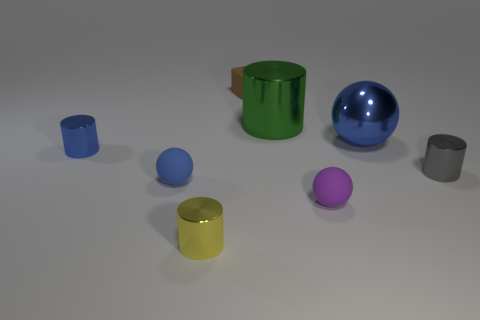Add 2 metal balls. How many objects exist? 10 Subtract all balls. How many objects are left? 5 Add 7 big brown metallic balls. How many big brown metallic balls exist? 7 Subtract 0 brown cylinders. How many objects are left? 8 Subtract all blue objects. Subtract all tiny gray metal objects. How many objects are left? 4 Add 5 gray metallic cylinders. How many gray metallic cylinders are left? 6 